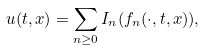Convert formula to latex. <formula><loc_0><loc_0><loc_500><loc_500>u ( t , x ) = \sum _ { n \geq 0 } I _ { n } ( f _ { n } ( \cdot , t , x ) ) ,</formula> 